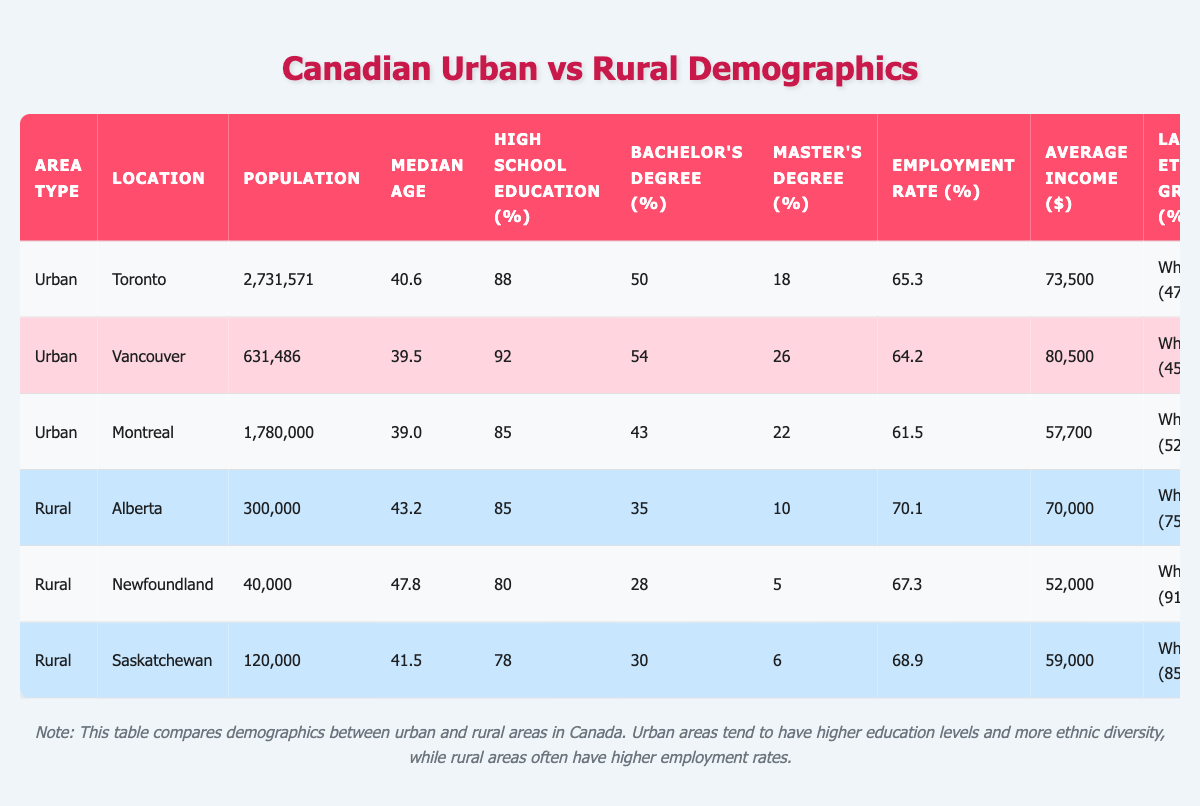What is the population of Toronto? From the table, under the Urban area section, we see that the population entry for Toronto is 2,731,571, directly stated in the table.
Answer: 2,731,571 Which urban area has the highest employment rate? According to the table, the employment rates listed for the urban areas are 65.3% for Toronto, 64.2% for Vancouver, and 61.5% for Montreal. The highest is thus 65.3%, associated with Toronto.
Answer: Toronto What percentage of the population in Newfoundland has a Master's Degree? In the Rural section for Newfoundland, the percentage listed for individuals with a Master's Degree is 5%. This is explicitly found in the table.
Answer: 5% Which urban area has the lowest average income? The average incomes for the urban areas are 73,500 for Toronto, 80,500 for Vancouver, and 57,700 for Montreal. The lowest average income, as per the table, is for Montreal at 57,700.
Answer: Montreal Is the majority ethnic group in Saskatchewan Indigenous? The largest ethnic group percentage in Saskatchewan is 85% White, based on the table. Since this does not exceed 50% for Indigenous, the statement is false.
Answer: No What is the average employment rate for urban areas? The employment rates for urban areas are 65.3% for Toronto, 64.2% for Vancouver, and 61.5% for Montreal. Summing these gives 65.3 + 64.2 + 61.5 = 191. The average is then 191 divided by 3, which equals approximately 63.67%.
Answer: Approximately 63.67% Which area has a higher median age, rural Alberta or urban Vancouver? In the Rural section, Alberta has a median age of 43.2 years, while Vancouver in the Urban section has a median age of 39.5 years. Comparing these figures, Alberta's median age is higher.
Answer: Rural Alberta What percentage of the population in Toronto has at least a Bachelor's Degree? From the table, 50% of the population in Toronto holds a Bachelor's Degree. To find this percentage of the population, we consider it's already stated as 50%.
Answer: 50% Which region has the lowest median age? The median ages listed are 40.6 for Toronto, 39.5 for Vancouver, 39.0 for Montreal, 43.2 for Alberta, 47.8 for Newfoundland, and 41.5 for Saskatchewan. The lowest of these is 39.0 for Montreal.
Answer: Montreal What is the total population of all urban areas combined? The populations of the urban areas are: 2,731,571 (Toronto) + 631,486 (Vancouver) + 1,780,000 (Montreal) = 5,143,057. Thus, adding these gives a total population of 5,143,057 for urban areas.
Answer: 5,143,057 Which ethnic group has the highest representation in the rural population of Alberta? According to the table data, the ethnic diversity for rural Alberta shows that the White group represents 75% of the population, which is the highest percentage compared to the Indigenous (15.5%) and Others (9.5%).
Answer: White group 